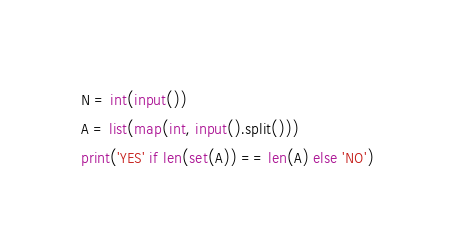Convert code to text. <code><loc_0><loc_0><loc_500><loc_500><_Python_>N = int(input())
A = list(map(int, input().split()))
print('YES' if len(set(A)) == len(A) else 'NO')
</code> 